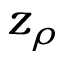<formula> <loc_0><loc_0><loc_500><loc_500>z _ { \rho }</formula> 